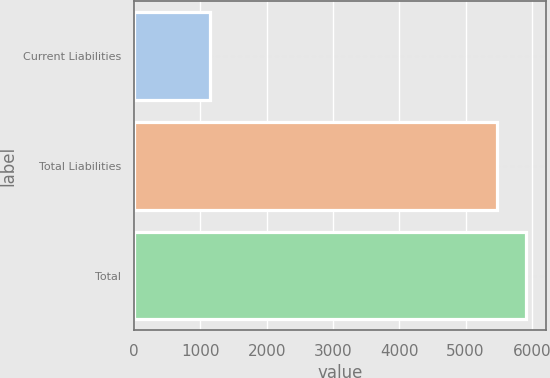<chart> <loc_0><loc_0><loc_500><loc_500><bar_chart><fcel>Current Liabilities<fcel>Total Liabilities<fcel>Total<nl><fcel>1147<fcel>5479<fcel>5912.2<nl></chart> 